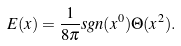Convert formula to latex. <formula><loc_0><loc_0><loc_500><loc_500>E ( x ) = \frac { 1 } { 8 \pi } s g n ( x ^ { 0 } ) \Theta ( x ^ { 2 } ) .</formula> 